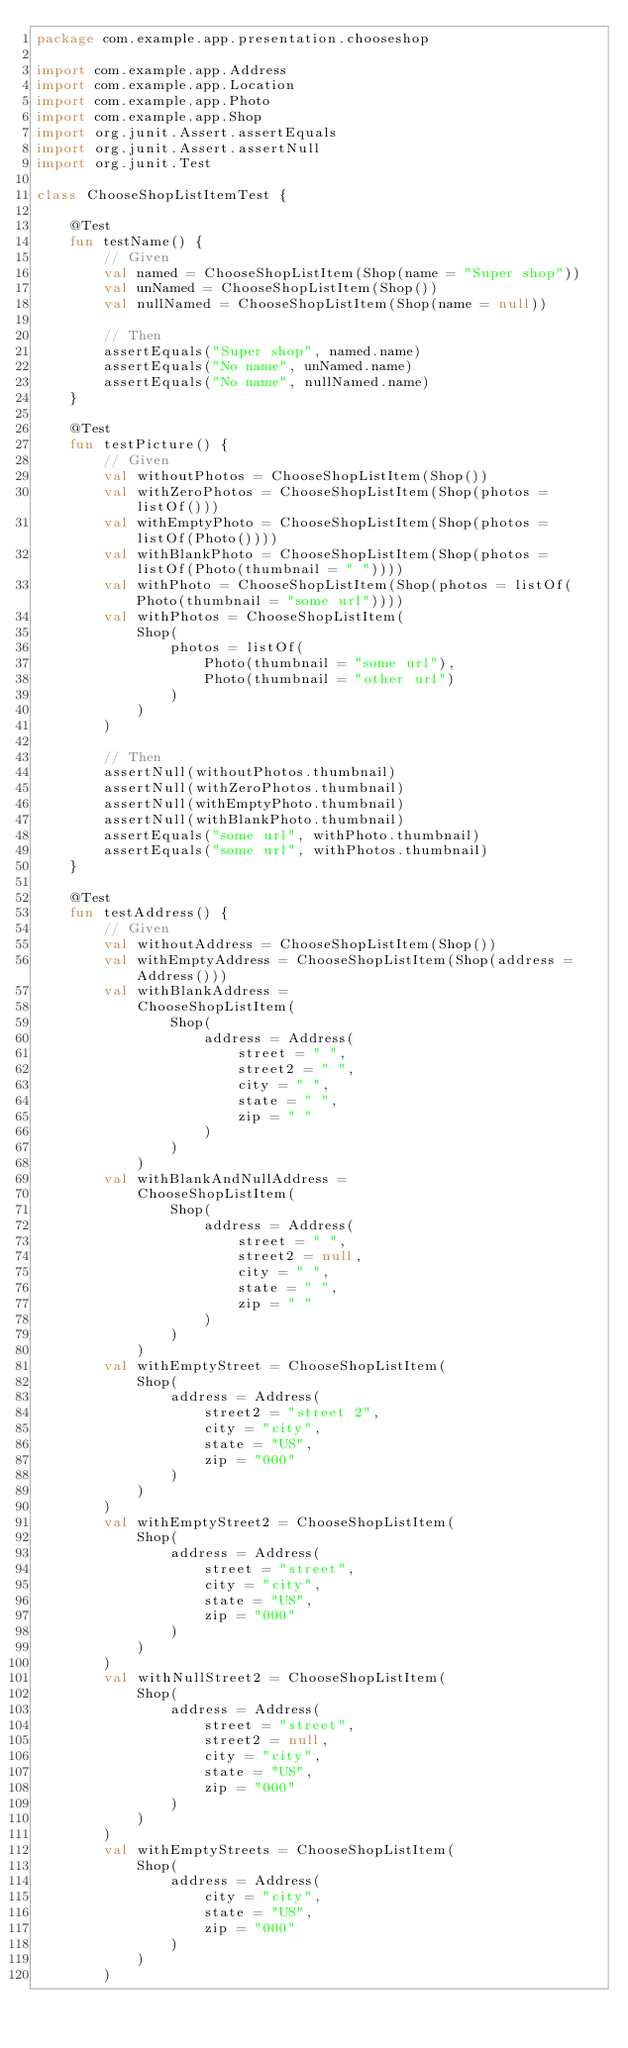<code> <loc_0><loc_0><loc_500><loc_500><_Kotlin_>package com.example.app.presentation.chooseshop

import com.example.app.Address
import com.example.app.Location
import com.example.app.Photo
import com.example.app.Shop
import org.junit.Assert.assertEquals
import org.junit.Assert.assertNull
import org.junit.Test

class ChooseShopListItemTest {

    @Test
    fun testName() {
        // Given
        val named = ChooseShopListItem(Shop(name = "Super shop"))
        val unNamed = ChooseShopListItem(Shop())
        val nullNamed = ChooseShopListItem(Shop(name = null))

        // Then
        assertEquals("Super shop", named.name)
        assertEquals("No name", unNamed.name)
        assertEquals("No name", nullNamed.name)
    }

    @Test
    fun testPicture() {
        // Given
        val withoutPhotos = ChooseShopListItem(Shop())
        val withZeroPhotos = ChooseShopListItem(Shop(photos = listOf()))
        val withEmptyPhoto = ChooseShopListItem(Shop(photos = listOf(Photo())))
        val withBlankPhoto = ChooseShopListItem(Shop(photos = listOf(Photo(thumbnail = " "))))
        val withPhoto = ChooseShopListItem(Shop(photos = listOf(Photo(thumbnail = "some url"))))
        val withPhotos = ChooseShopListItem(
            Shop(
                photos = listOf(
                    Photo(thumbnail = "some url"),
                    Photo(thumbnail = "other url")
                )
            )
        )

        // Then
        assertNull(withoutPhotos.thumbnail)
        assertNull(withZeroPhotos.thumbnail)
        assertNull(withEmptyPhoto.thumbnail)
        assertNull(withBlankPhoto.thumbnail)
        assertEquals("some url", withPhoto.thumbnail)
        assertEquals("some url", withPhotos.thumbnail)
    }

    @Test
    fun testAddress() {
        // Given
        val withoutAddress = ChooseShopListItem(Shop())
        val withEmptyAddress = ChooseShopListItem(Shop(address = Address()))
        val withBlankAddress =
            ChooseShopListItem(
                Shop(
                    address = Address(
                        street = " ",
                        street2 = " ",
                        city = " ",
                        state = " ",
                        zip = " "
                    )
                )
            )
        val withBlankAndNullAddress =
            ChooseShopListItem(
                Shop(
                    address = Address(
                        street = " ",
                        street2 = null,
                        city = " ",
                        state = " ",
                        zip = " "
                    )
                )
            )
        val withEmptyStreet = ChooseShopListItem(
            Shop(
                address = Address(
                    street2 = "street 2",
                    city = "city",
                    state = "US",
                    zip = "000"
                )
            )
        )
        val withEmptyStreet2 = ChooseShopListItem(
            Shop(
                address = Address(
                    street = "street",
                    city = "city",
                    state = "US",
                    zip = "000"
                )
            )
        )
        val withNullStreet2 = ChooseShopListItem(
            Shop(
                address = Address(
                    street = "street",
                    street2 = null,
                    city = "city",
                    state = "US",
                    zip = "000"
                )
            )
        )
        val withEmptyStreets = ChooseShopListItem(
            Shop(
                address = Address(
                    city = "city",
                    state = "US",
                    zip = "000"
                )
            )
        )</code> 